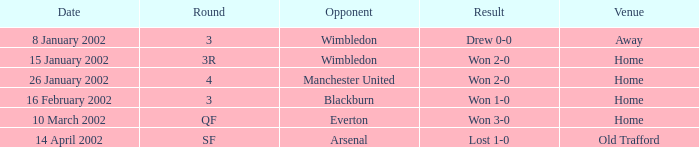What is the Date with an Opponent with wimbledon, and a Result of drew 0-0? 8 January 2002. 